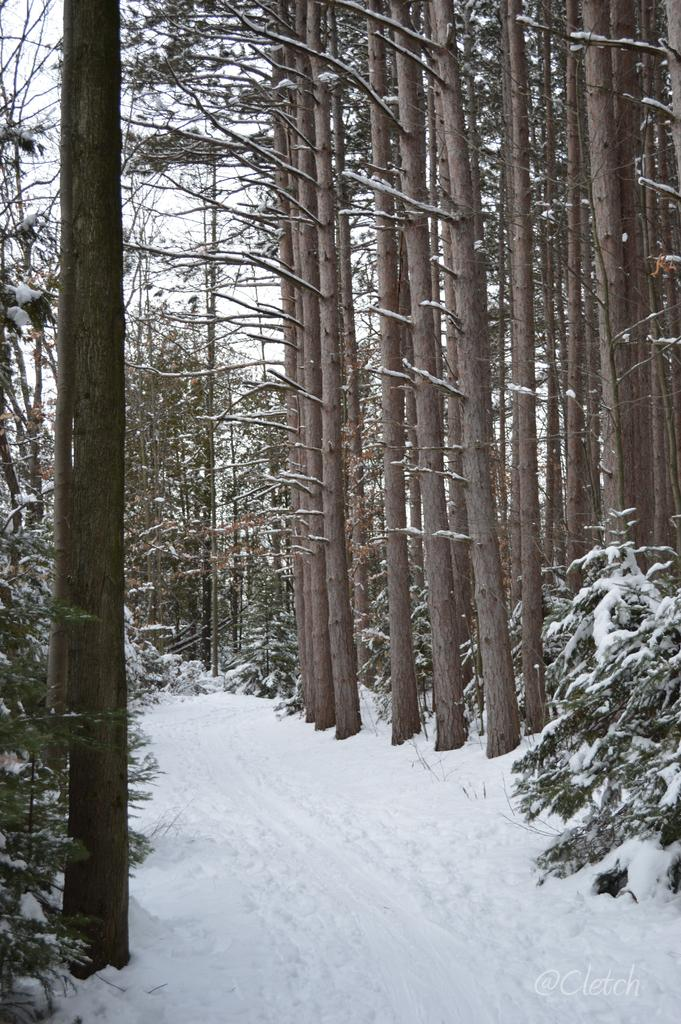What type of vegetation can be seen in the image? There are trees in the image. What time period does the image represent? The image represents the present time (now). What part of the natural environment is visible in the image? The sky is visible in the image. What is the weight of the steam coming from the trees in the image? There is no steam present in the image, and therefore no weight can be determined. 